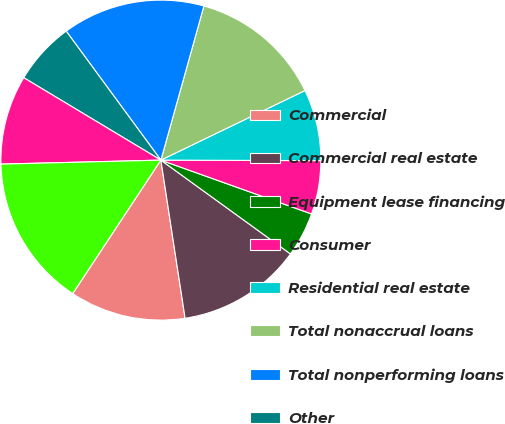Convert chart. <chart><loc_0><loc_0><loc_500><loc_500><pie_chart><fcel>Commercial<fcel>Commercial real estate<fcel>Equipment lease financing<fcel>Consumer<fcel>Residential real estate<fcel>Total nonaccrual loans<fcel>Total nonperforming loans<fcel>Other<fcel>Total foreclosed and other<fcel>Total nonperforming assets (b)<nl><fcel>11.71%<fcel>12.61%<fcel>4.51%<fcel>5.41%<fcel>7.21%<fcel>13.51%<fcel>14.41%<fcel>6.31%<fcel>9.01%<fcel>15.31%<nl></chart> 